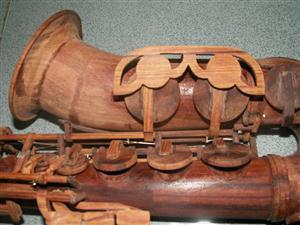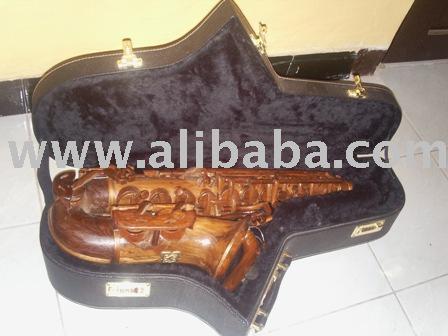The first image is the image on the left, the second image is the image on the right. Given the left and right images, does the statement "At least one image has no background." hold true? Answer yes or no. No. The first image is the image on the left, the second image is the image on the right. Examine the images to the left and right. Is the description "The image on the right contains a single saxophone on a white background." accurate? Answer yes or no. No. 